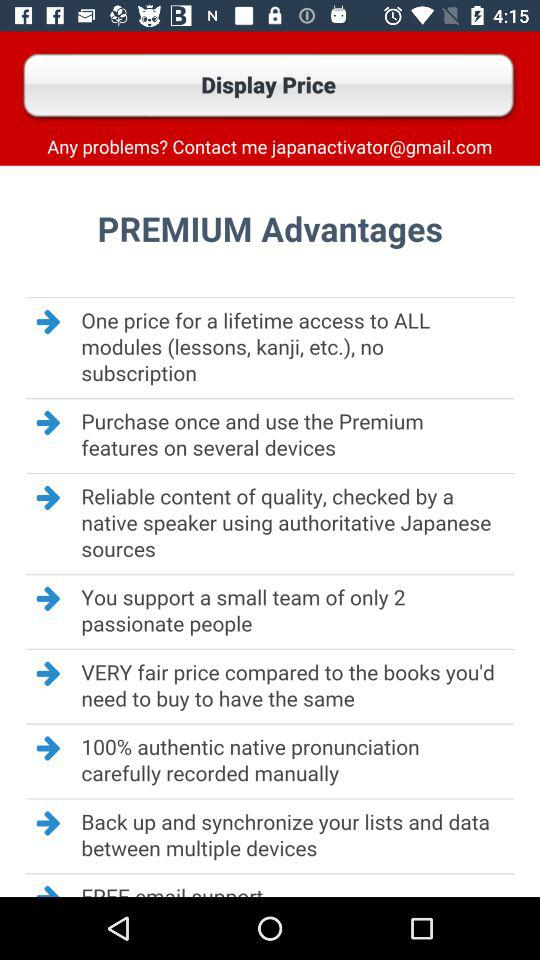What is the email address? The email address is japanactivator@gmail.com. 